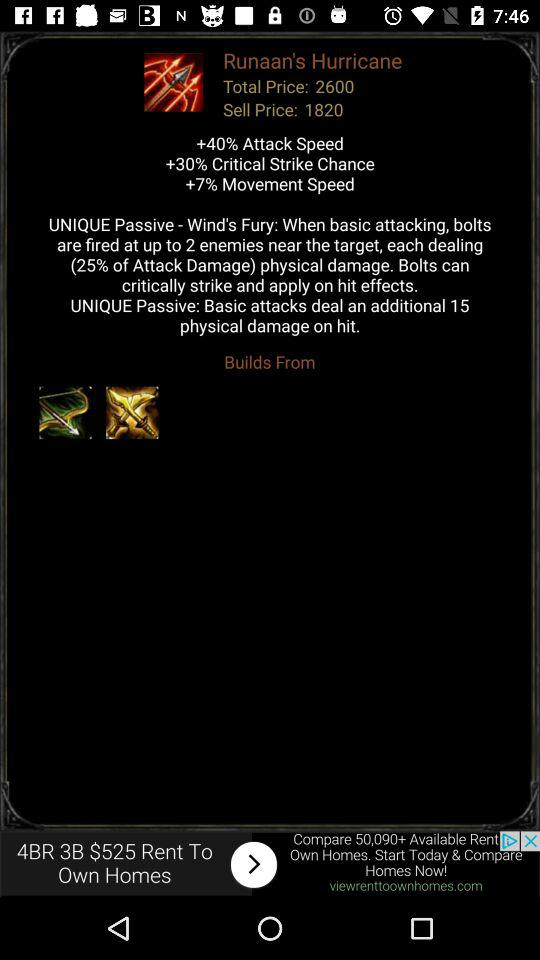What is the total price? The total price is 2600. 